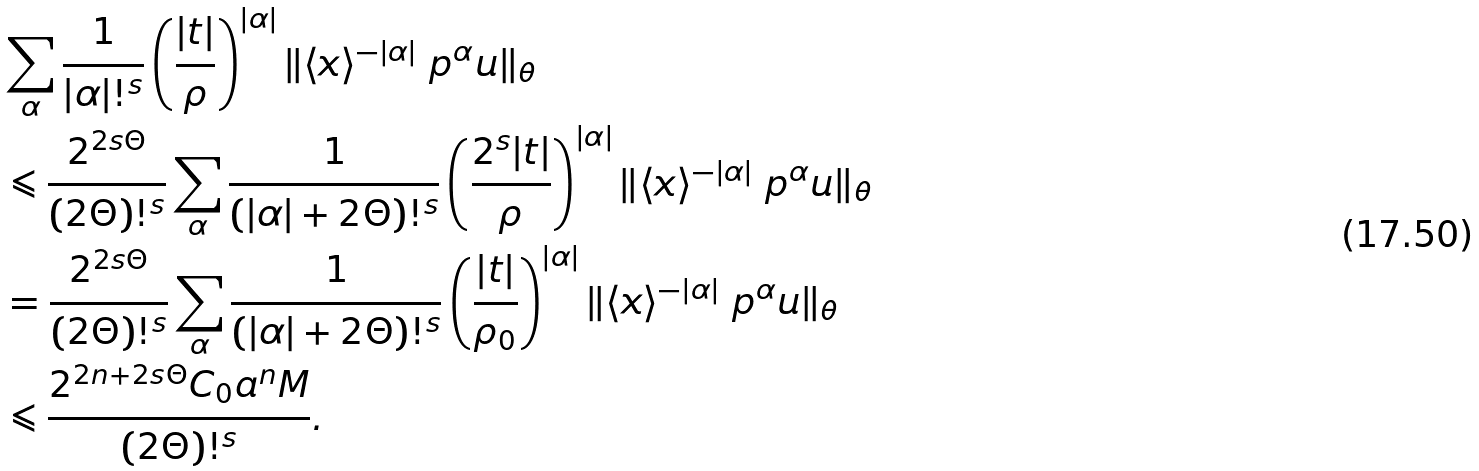Convert formula to latex. <formula><loc_0><loc_0><loc_500><loc_500>& \sum _ { \alpha } \frac { 1 } { | \alpha | ! ^ { s } } \left ( \frac { | { t } | } { \rho } \right ) ^ { | \alpha | } \| \langle { x } \rangle ^ { - | \alpha | } \ p ^ { \alpha } { u } \| _ { \theta } \\ & \leqslant \frac { 2 ^ { 2 s \Theta } } { ( 2 \Theta ) ! ^ { s } } \sum _ { \alpha } \frac { 1 } { ( | \alpha | + 2 \Theta ) ! ^ { s } } \left ( \frac { 2 ^ { s } | { t } | } { \rho } \right ) ^ { | \alpha | } \| \langle { x } \rangle ^ { - | \alpha | } \ p ^ { \alpha } { u } \| _ { \theta } \\ & = \frac { 2 ^ { 2 s \Theta } } { ( 2 \Theta ) ! ^ { s } } \sum _ { \alpha } \frac { 1 } { ( | \alpha | + 2 \Theta ) ! ^ { s } } \left ( \frac { | { t } | } { \rho _ { 0 } } \right ) ^ { | \alpha | } \| \langle { x } \rangle ^ { - | \alpha | } \ p ^ { \alpha } { u } \| _ { \theta } \\ & \leqslant \frac { 2 ^ { 2 n + 2 s \Theta } C _ { 0 } a ^ { n } M } { ( 2 \Theta ) ! ^ { s } } .</formula> 